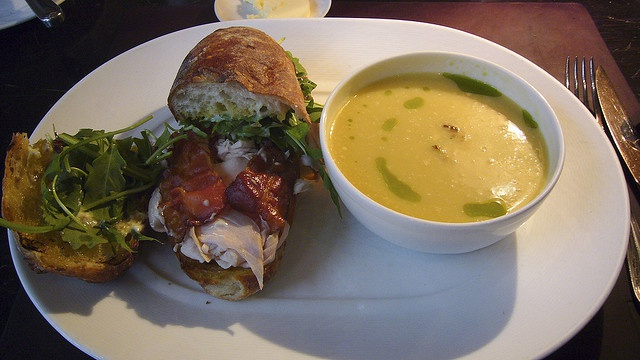Describe the objects in this image and their specific colors. I can see bowl in gray, tan, orange, darkgray, and olive tones, sandwich in gray, black, maroon, and olive tones, sandwich in gray, black, olive, and maroon tones, knife in gray, maroon, and brown tones, and fork in gray, black, maroon, and brown tones in this image. 